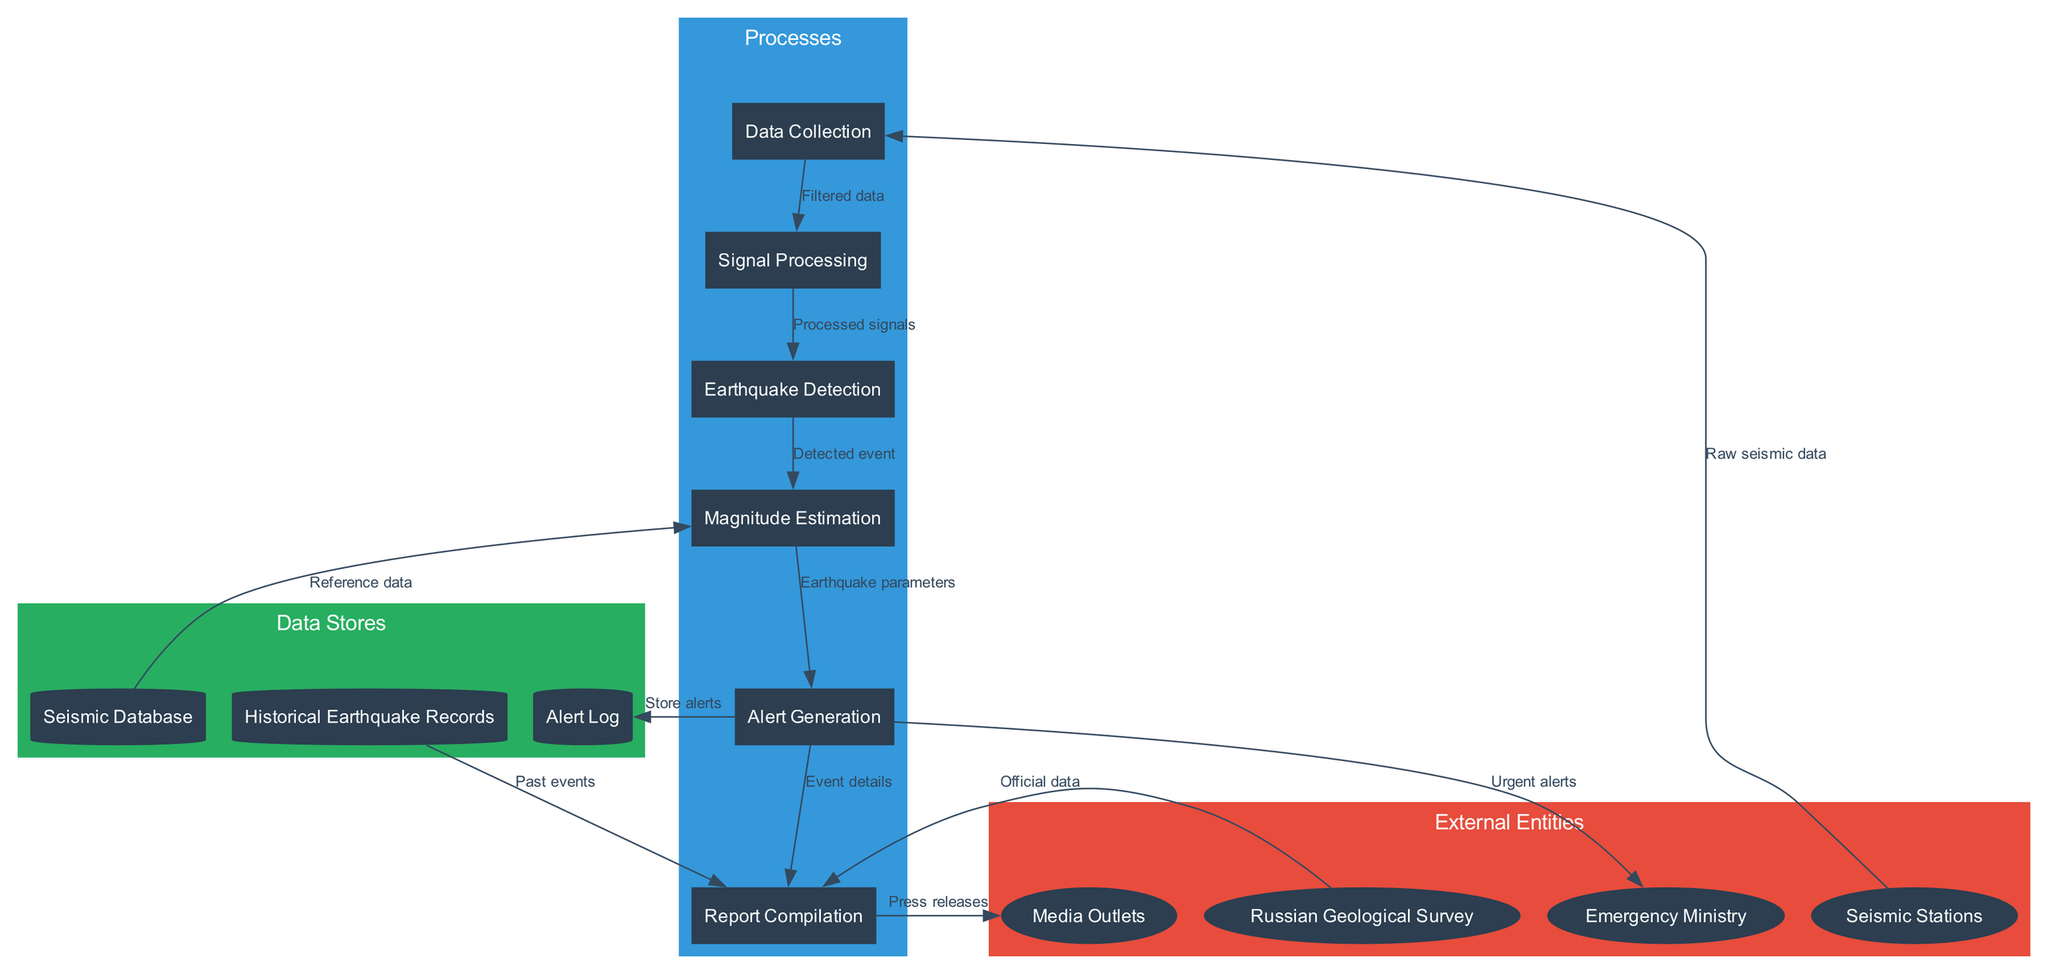What are the external entities involved in the diagram? The diagram features four external entities: Seismic Stations, Russian Geological Survey, Emergency Ministry, and Media Outlets, which are located in the "External Entities" section of the diagram.
Answer: Seismic Stations, Russian Geological Survey, Emergency Ministry, Media Outlets How many processes are defined in the diagram? The diagram lists six processes: Data Collection, Signal Processing, Earthquake Detection, Magnitude Estimation, Alert Generation, and Report Compilation. Counting these processes gives us a total of six.
Answer: 6 What type of data flow occurs from Signal Processing to Earthquake Detection? The data flow from Signal Processing to Earthquake Detection is labeled as "Processed signals," which indicates that the signals have been processed before detection occurs.
Answer: Processed signals Which data store provides reference data for magnitude estimation? The Seismic Database is the data store that supplies the reference data necessary for the magnitude estimation process.
Answer: Seismic Database How many data flows go from Alert Generation to other nodes? There are three data flows originating from Alert Generation: to Emergency Ministry, Report Compilation, and Alert Log. Counting these flows reveals that there are three outgoing connections.
Answer: 3 What type of data is sent to Media Outlets? The data sent to Media Outlets is categorized as "Press releases," which are prepared during the report compilation process and shared externally.
Answer: Press releases What action does the Emergency Ministry take upon receiving alerts? Upon receiving alerts from Alert Generation, the Emergency Ministry takes action based on the "Urgent alerts" they receive, indicating immediate attention to potential emergencies.
Answer: Urgent alerts What information is provided from Historical Earthquake Records to Report Compilation? Historical Earthquake Records contribute "Past events" to the Report Compilation process, which leverages historical data in preparing current reports.
Answer: Past events Which two nodes directly connect to Report Compilation? Report Compilation is directly connected to two nodes: Alert Generation (providing event details) and the Russian Geological Survey (providing official data), showing its interaction with these processes.
Answer: Alert Generation, Russian Geological Survey 